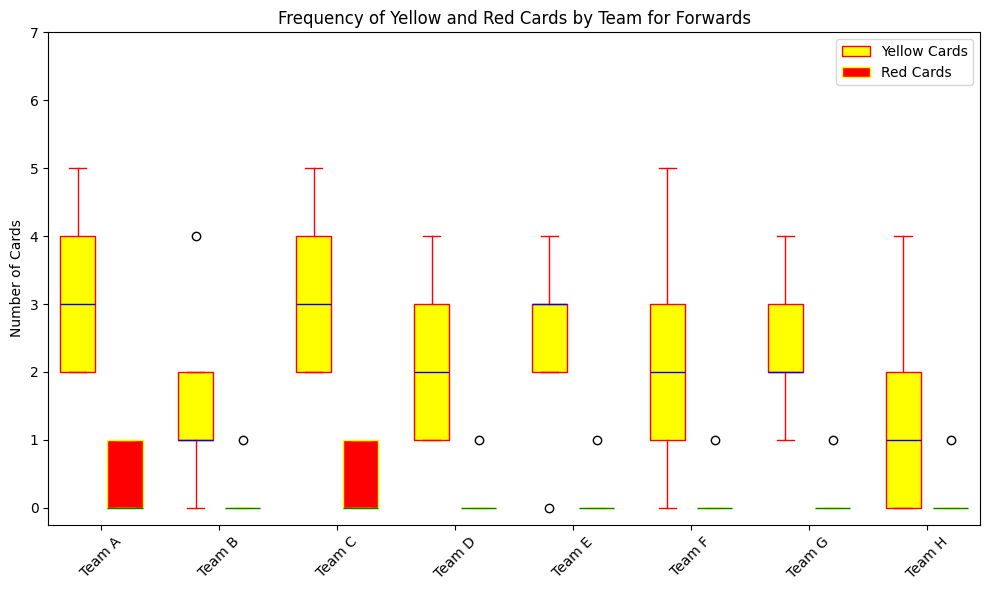Which team has the highest median number of yellow cards? To find the team with the highest median number of yellow cards, look at the middle line in the yellow box plots for each team. Team F has the highest median as the middle line in its yellow box plot is higher than the others.
Answer: Team F Which teams have the lowest minimum number of red cards? Examine the lowest point of the red box plots for each team. Teams with the lowest minimum number of red cards have this point at 0. These teams are Team B, Team D, Team E, Team F, Team G, and Team H.
Answer: Team B, Team D, Team E, Team F, Team G, Team H What is the interquartile range (IQR) of yellow cards received by Team A? The IQR is the difference between the upper quartile (75th percentile) and the lower quartile (25th percentile). For Team A's yellow cards, identify these values from the yellow box plot and calculate the difference. The lower quartile is 2 and the upper quartile is 4, so the IQR is 4 - 2 = 2.
Answer: 2 Which team has greater variability in the number of yellow cards received, Team A or Team B? Variability can be observed through the spread of the box plots. The range from the lowest to highest values and the spread from the bottom to top of the box should be compared. Team A's box plot is more spread out compared to Team B's, indicating greater variability.
Answer: Team A For which team are the median yellow and red cards equal? Look for a team where the middle lines (medians) of the yellow and red box plots are at the same level. None of the teams have equal medians for yellow and red cards. Each team's medians are at different levels.
Answer: None What is the range of red cards received by Team G? The range is the difference between the maximum and minimum values of the red cards for Team G. The red box plot's top whisker point is at 1, and the bottom whisker point is at 0. Therefore, the range is 1 - 0 = 1.
Answer: 1 Which team has the smallest median number of yellow cards? To find the smallest median, look at the middle line in the yellow box plots and find the lowest. Team B and Team D both have their median yellow cards as the lowest.
Answer: Team B, Team D How does the frequency of yellow cards received by forwards in Team H compare to Team C? Look at the box plots for yellow cards of both teams. Team H's plot is lower and more compressed around lower values while Team C’s plot is higher and more spread out. Team C has higher and more variable yellow cards frequency than Team H.
Answer: Team C has higher and more variable frequency Which team received at least one red card in all cases? Check if any team's red box plot has its minimum value above 0. Team A is the only team with all its lower whiskers above 0, indicating they received at least one red card in all cases.
Answer: Team A 